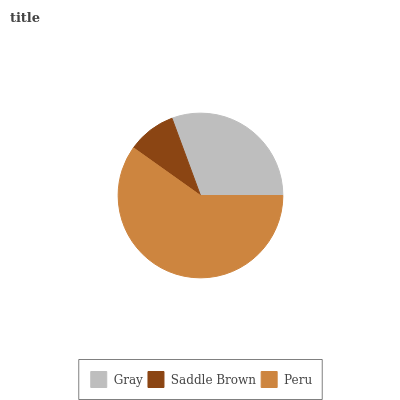Is Saddle Brown the minimum?
Answer yes or no. Yes. Is Peru the maximum?
Answer yes or no. Yes. Is Peru the minimum?
Answer yes or no. No. Is Saddle Brown the maximum?
Answer yes or no. No. Is Peru greater than Saddle Brown?
Answer yes or no. Yes. Is Saddle Brown less than Peru?
Answer yes or no. Yes. Is Saddle Brown greater than Peru?
Answer yes or no. No. Is Peru less than Saddle Brown?
Answer yes or no. No. Is Gray the high median?
Answer yes or no. Yes. Is Gray the low median?
Answer yes or no. Yes. Is Peru the high median?
Answer yes or no. No. Is Peru the low median?
Answer yes or no. No. 